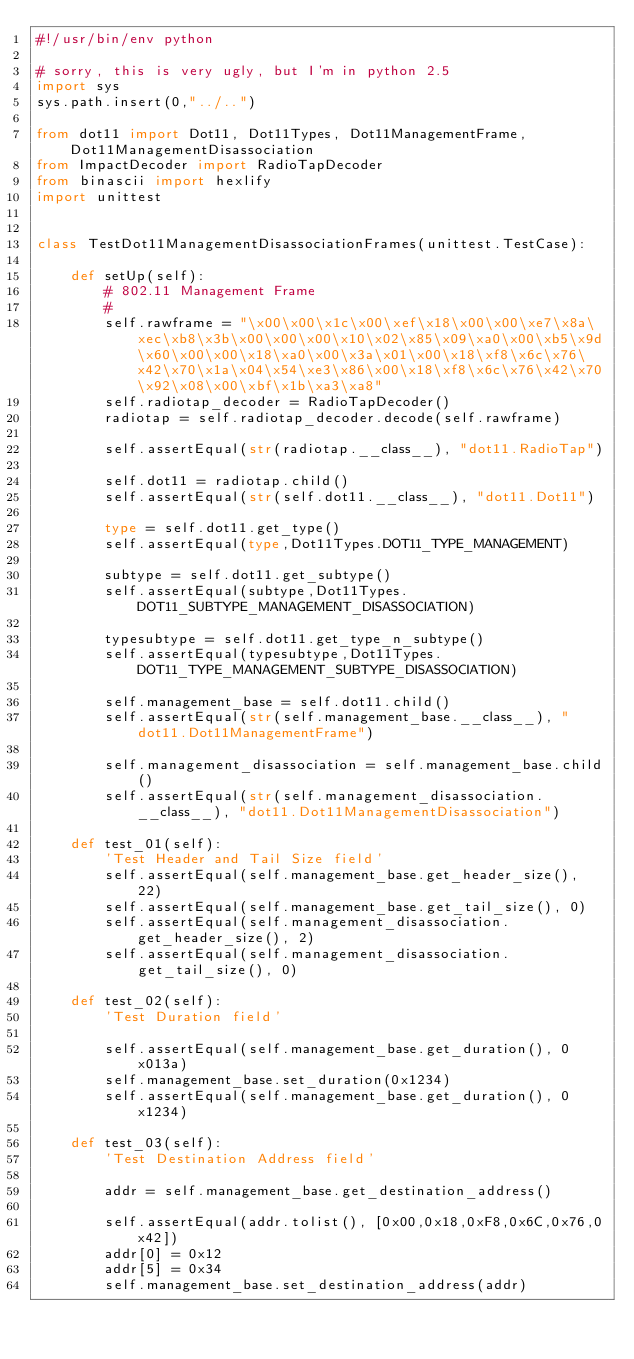<code> <loc_0><loc_0><loc_500><loc_500><_Python_>#!/usr/bin/env python

# sorry, this is very ugly, but I'm in python 2.5
import sys
sys.path.insert(0,"../..")

from dot11 import Dot11, Dot11Types, Dot11ManagementFrame,Dot11ManagementDisassociation
from ImpactDecoder import RadioTapDecoder
from binascii import hexlify
import unittest


class TestDot11ManagementDisassociationFrames(unittest.TestCase):

    def setUp(self):
        # 802.11 Management Frame
        #
        self.rawframe = "\x00\x00\x1c\x00\xef\x18\x00\x00\xe7\x8a\xec\xb8\x3b\x00\x00\x00\x10\x02\x85\x09\xa0\x00\xb5\x9d\x60\x00\x00\x18\xa0\x00\x3a\x01\x00\x18\xf8\x6c\x76\x42\x70\x1a\x04\x54\xe3\x86\x00\x18\xf8\x6c\x76\x42\x70\x92\x08\x00\xbf\x1b\xa3\xa8"
        self.radiotap_decoder = RadioTapDecoder()
        radiotap = self.radiotap_decoder.decode(self.rawframe)

        self.assertEqual(str(radiotap.__class__), "dot11.RadioTap")

        self.dot11 = radiotap.child()
        self.assertEqual(str(self.dot11.__class__), "dot11.Dot11")

        type = self.dot11.get_type()
        self.assertEqual(type,Dot11Types.DOT11_TYPE_MANAGEMENT)

        subtype = self.dot11.get_subtype()
        self.assertEqual(subtype,Dot11Types.DOT11_SUBTYPE_MANAGEMENT_DISASSOCIATION)

        typesubtype = self.dot11.get_type_n_subtype()
        self.assertEqual(typesubtype,Dot11Types.DOT11_TYPE_MANAGEMENT_SUBTYPE_DISASSOCIATION)

        self.management_base = self.dot11.child()
        self.assertEqual(str(self.management_base.__class__), "dot11.Dot11ManagementFrame")

        self.management_disassociation = self.management_base.child()
        self.assertEqual(str(self.management_disassociation.__class__), "dot11.Dot11ManagementDisassociation")

    def test_01(self):
        'Test Header and Tail Size field'
        self.assertEqual(self.management_base.get_header_size(), 22)
        self.assertEqual(self.management_base.get_tail_size(), 0)
        self.assertEqual(self.management_disassociation.get_header_size(), 2)
        self.assertEqual(self.management_disassociation.get_tail_size(), 0)

    def test_02(self):
        'Test Duration field'

        self.assertEqual(self.management_base.get_duration(), 0x013a)
        self.management_base.set_duration(0x1234)
        self.assertEqual(self.management_base.get_duration(), 0x1234)

    def test_03(self):
        'Test Destination Address field'

        addr = self.management_base.get_destination_address()

        self.assertEqual(addr.tolist(), [0x00,0x18,0xF8,0x6C,0x76,0x42])
        addr[0] = 0x12
        addr[5] = 0x34
        self.management_base.set_destination_address(addr)</code> 